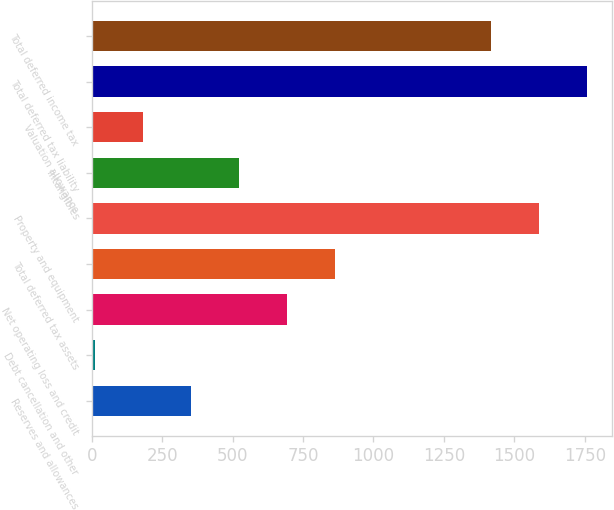Convert chart. <chart><loc_0><loc_0><loc_500><loc_500><bar_chart><fcel>Reserves and allowances<fcel>Debt cancellation and other<fcel>Net operating loss and credit<fcel>Total deferred tax assets<fcel>Property and equipment<fcel>Intangibles<fcel>Valuation allowance<fcel>Total deferred tax liability<fcel>Total deferred income tax<nl><fcel>352.6<fcel>13<fcel>692.2<fcel>862<fcel>1588.8<fcel>522.4<fcel>182.8<fcel>1758.6<fcel>1419<nl></chart> 